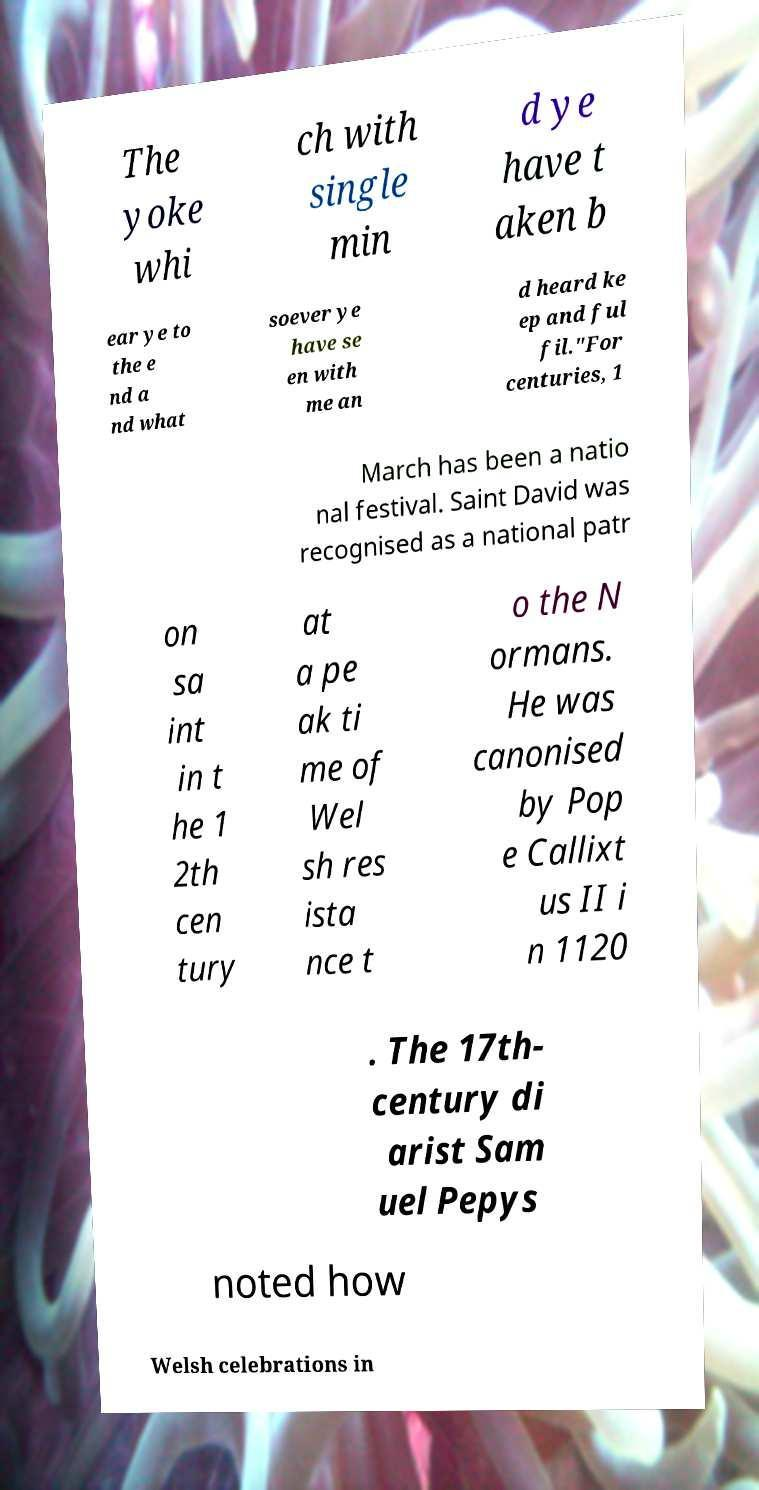Can you read and provide the text displayed in the image?This photo seems to have some interesting text. Can you extract and type it out for me? The yoke whi ch with single min d ye have t aken b ear ye to the e nd a nd what soever ye have se en with me an d heard ke ep and ful fil."For centuries, 1 March has been a natio nal festival. Saint David was recognised as a national patr on sa int in t he 1 2th cen tury at a pe ak ti me of Wel sh res ista nce t o the N ormans. He was canonised by Pop e Callixt us II i n 1120 . The 17th- century di arist Sam uel Pepys noted how Welsh celebrations in 